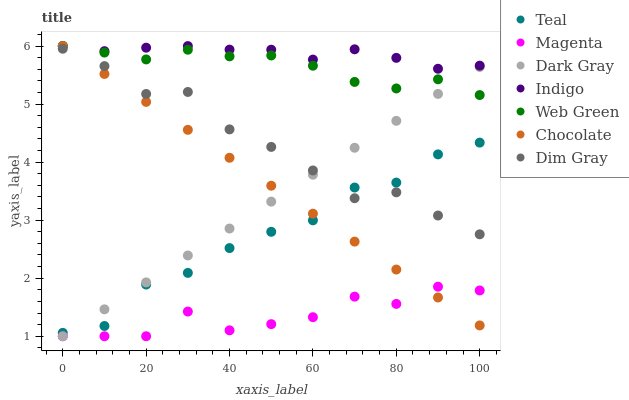Does Magenta have the minimum area under the curve?
Answer yes or no. Yes. Does Indigo have the maximum area under the curve?
Answer yes or no. Yes. Does Web Green have the minimum area under the curve?
Answer yes or no. No. Does Web Green have the maximum area under the curve?
Answer yes or no. No. Is Dark Gray the smoothest?
Answer yes or no. Yes. Is Magenta the roughest?
Answer yes or no. Yes. Is Indigo the smoothest?
Answer yes or no. No. Is Indigo the roughest?
Answer yes or no. No. Does Dark Gray have the lowest value?
Answer yes or no. Yes. Does Web Green have the lowest value?
Answer yes or no. No. Does Chocolate have the highest value?
Answer yes or no. Yes. Does Dark Gray have the highest value?
Answer yes or no. No. Is Dark Gray less than Indigo?
Answer yes or no. Yes. Is Indigo greater than Dark Gray?
Answer yes or no. Yes. Does Dim Gray intersect Dark Gray?
Answer yes or no. Yes. Is Dim Gray less than Dark Gray?
Answer yes or no. No. Is Dim Gray greater than Dark Gray?
Answer yes or no. No. Does Dark Gray intersect Indigo?
Answer yes or no. No. 